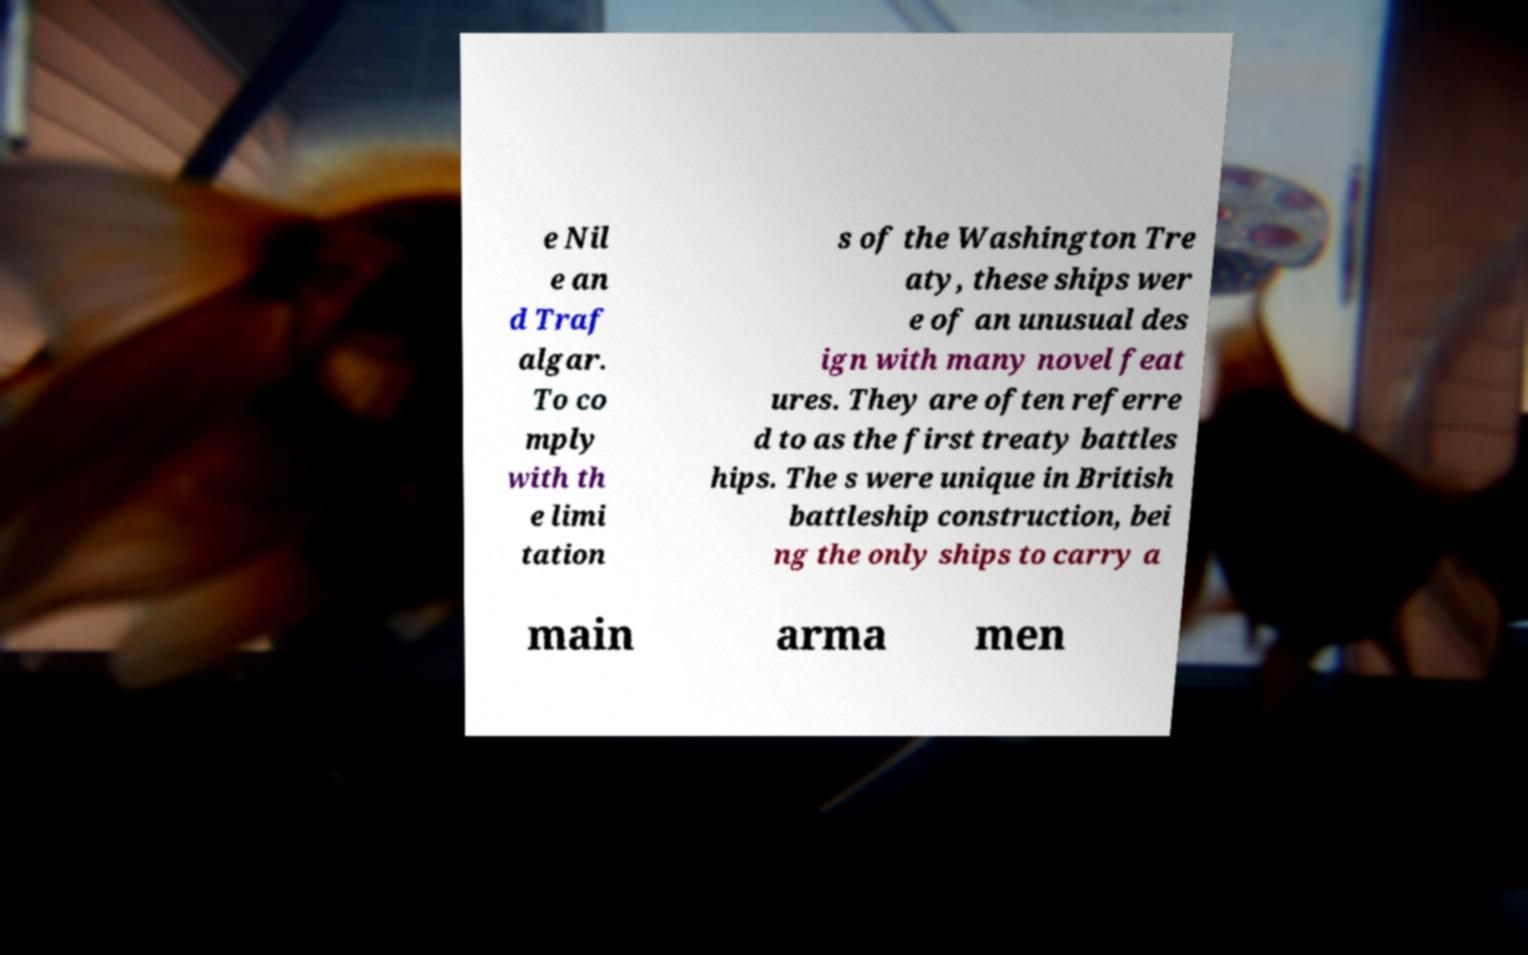For documentation purposes, I need the text within this image transcribed. Could you provide that? e Nil e an d Traf algar. To co mply with th e limi tation s of the Washington Tre aty, these ships wer e of an unusual des ign with many novel feat ures. They are often referre d to as the first treaty battles hips. The s were unique in British battleship construction, bei ng the only ships to carry a main arma men 